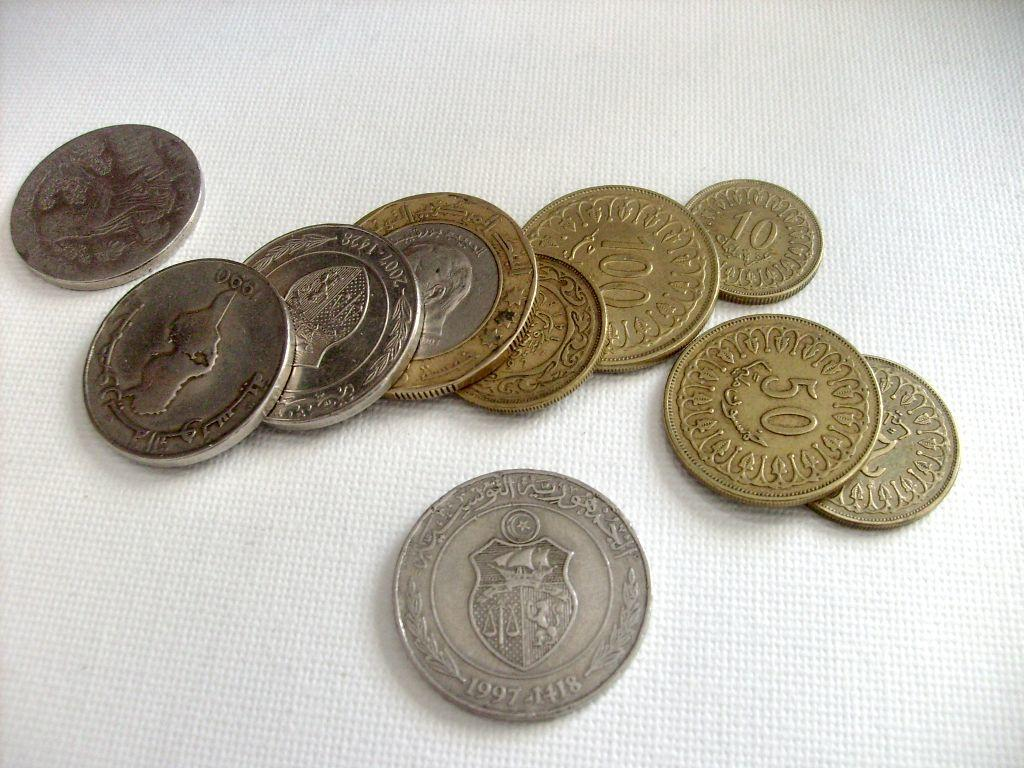<image>
Share a concise interpretation of the image provided. Handful of coins of various denominations with Arabic script. 